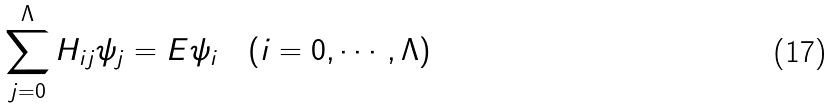Convert formula to latex. <formula><loc_0><loc_0><loc_500><loc_500>\sum _ { j = 0 } ^ { \Lambda } H _ { i j } \psi _ { j } = E \psi _ { i } \quad ( i = 0 , \cdots , \Lambda )</formula> 